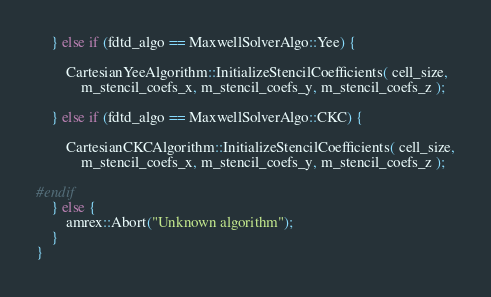Convert code to text. <code><loc_0><loc_0><loc_500><loc_500><_C++_>
    } else if (fdtd_algo == MaxwellSolverAlgo::Yee) {

        CartesianYeeAlgorithm::InitializeStencilCoefficients( cell_size,
            m_stencil_coefs_x, m_stencil_coefs_y, m_stencil_coefs_z );

    } else if (fdtd_algo == MaxwellSolverAlgo::CKC) {

        CartesianCKCAlgorithm::InitializeStencilCoefficients( cell_size,
            m_stencil_coefs_x, m_stencil_coefs_y, m_stencil_coefs_z );

#endif
    } else {
        amrex::Abort("Unknown algorithm");
    }
}
</code> 